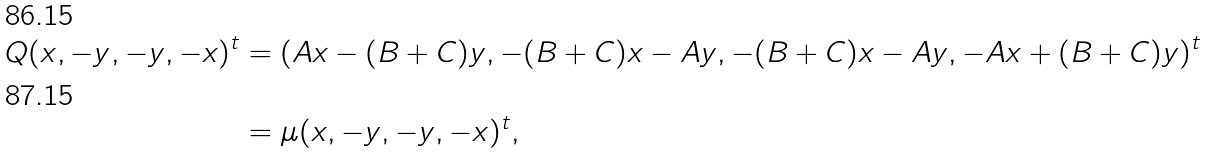Convert formula to latex. <formula><loc_0><loc_0><loc_500><loc_500>Q ( x , - y , - y , - x ) ^ { t } & = ( A x - ( B + C ) y , - ( B + C ) x - A y , - ( B + C ) x - A y , - A x + ( B + C ) y ) ^ { t } \\ & = \mu ( x , - y , - y , - x ) ^ { t } ,</formula> 